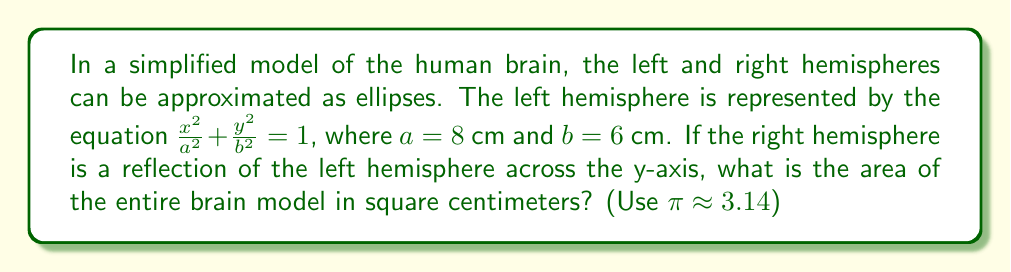What is the answer to this math problem? To solve this problem, we'll follow these steps:

1) First, recall that the area of an ellipse is given by the formula:
   $A = \pi ab$

2) For the left hemisphere:
   $a = 8$ cm and $b = 6$ cm
   $A_{left} = \pi (8)(6) = 48\pi$ cm²

3) The right hemisphere is a reflection of the left across the y-axis. This means it has the same dimensions and thus the same area as the left hemisphere:
   $A_{right} = 48\pi$ cm²

4) The total area of the brain model is the sum of both hemispheres:
   $A_{total} = A_{left} + A_{right} = 48\pi + 48\pi = 96\pi$ cm²

5) Using $\pi \approx 3.14$:
   $A_{total} \approx 96(3.14) = 301.44$ cm²

This model demonstrates rotational symmetry of order 2 around the z-axis (perpendicular to the xy-plane), and reflection symmetry across the y-axis, which aligns with the general symmetry observed in actual brain hemispheres.
Answer: The area of the entire brain model is approximately 301.44 cm². 